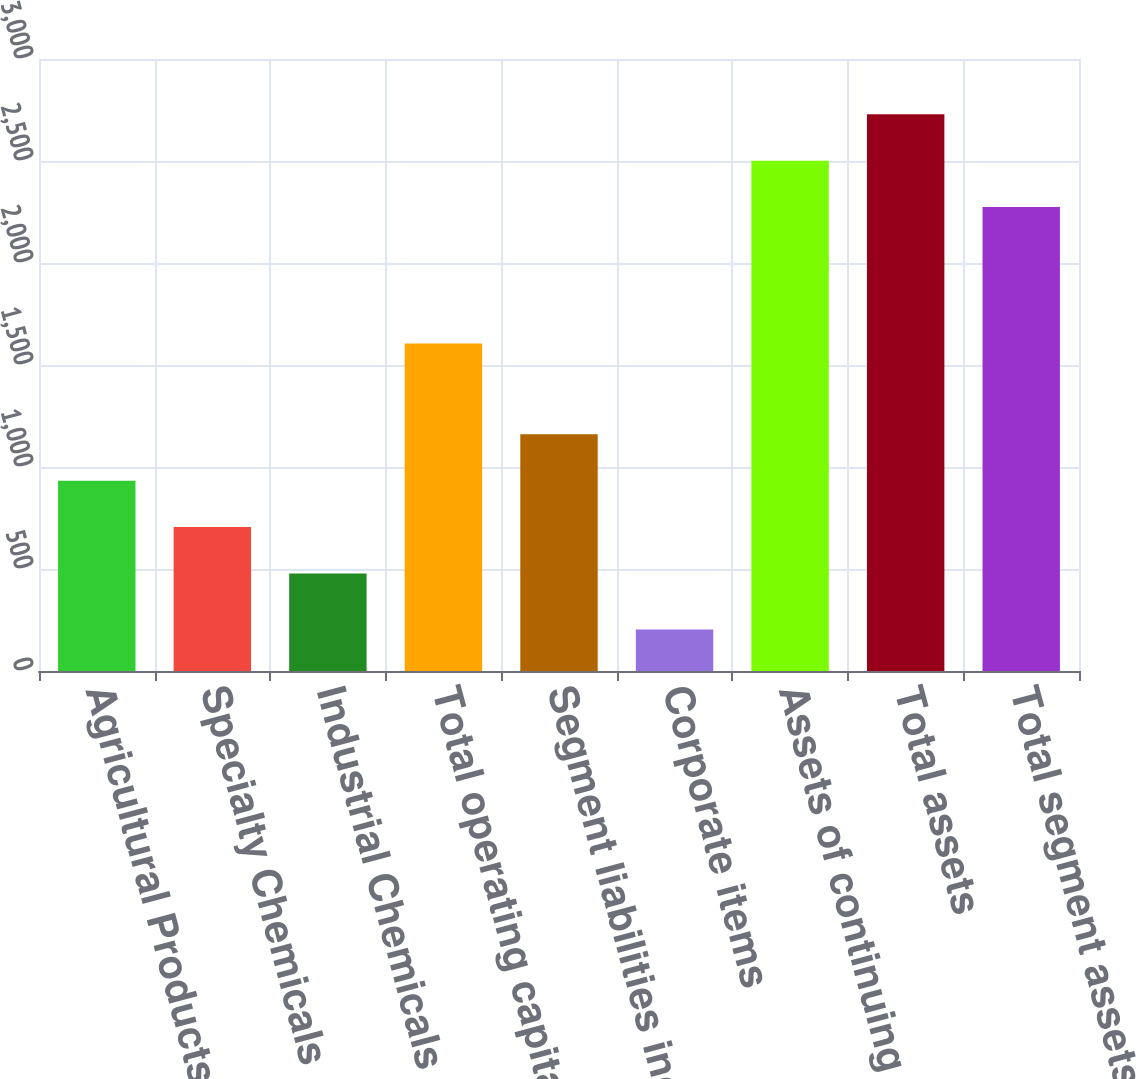<chart> <loc_0><loc_0><loc_500><loc_500><bar_chart><fcel>Agricultural Products<fcel>Specialty Chemicals<fcel>Industrial Chemicals<fcel>Total operating capital<fcel>Segment liabilities included<fcel>Corporate items<fcel>Assets of continuing<fcel>Total assets<fcel>Total segment assets<nl><fcel>932.76<fcel>705.33<fcel>477.9<fcel>1604.8<fcel>1160.19<fcel>202.9<fcel>2501.73<fcel>2729.16<fcel>2274.3<nl></chart> 